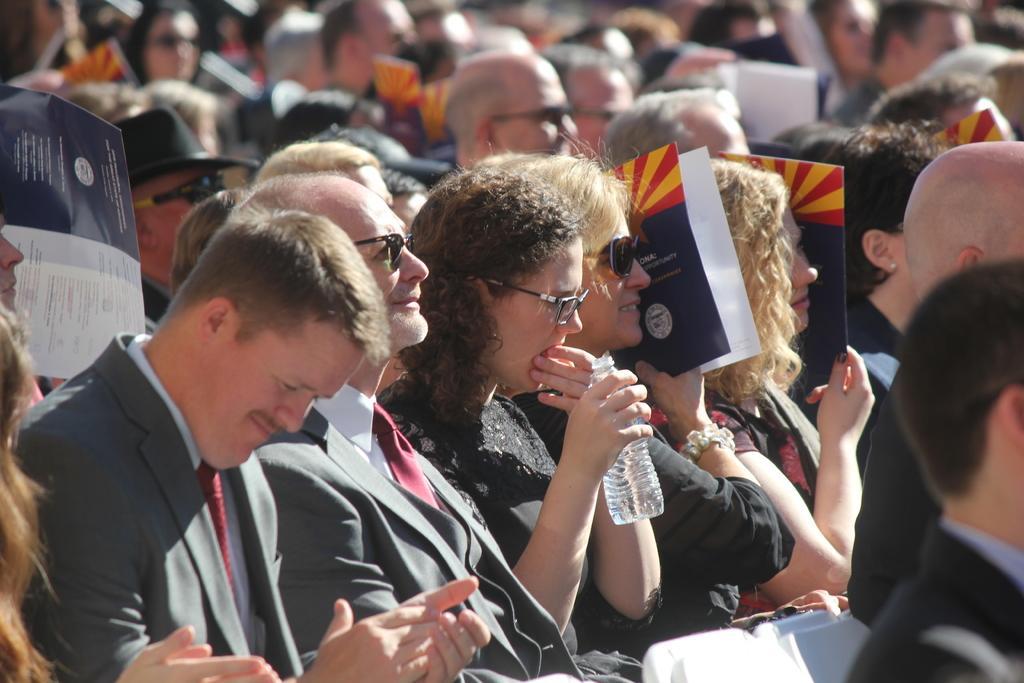Could you give a brief overview of what you see in this image? In this image there are many people sitting on the chairs. They are holding brochures in the hand. In the center there is a woman holding a water bottle in her hand. 